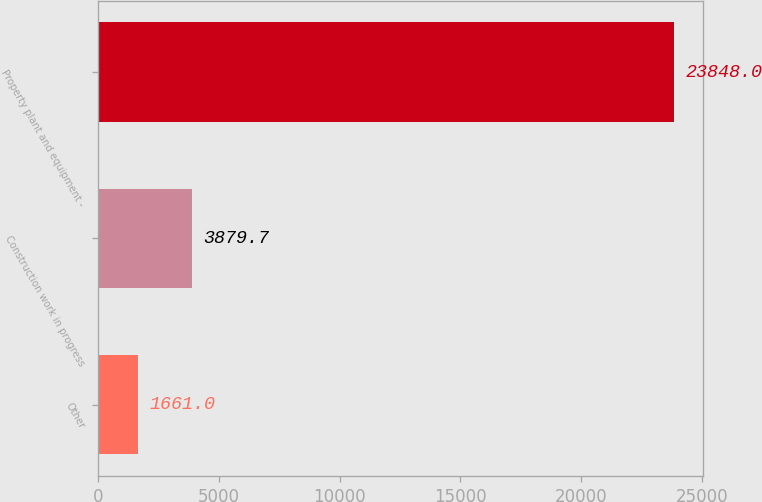<chart> <loc_0><loc_0><loc_500><loc_500><bar_chart><fcel>Other<fcel>Construction work in progress<fcel>Property plant and equipment -<nl><fcel>1661<fcel>3879.7<fcel>23848<nl></chart> 